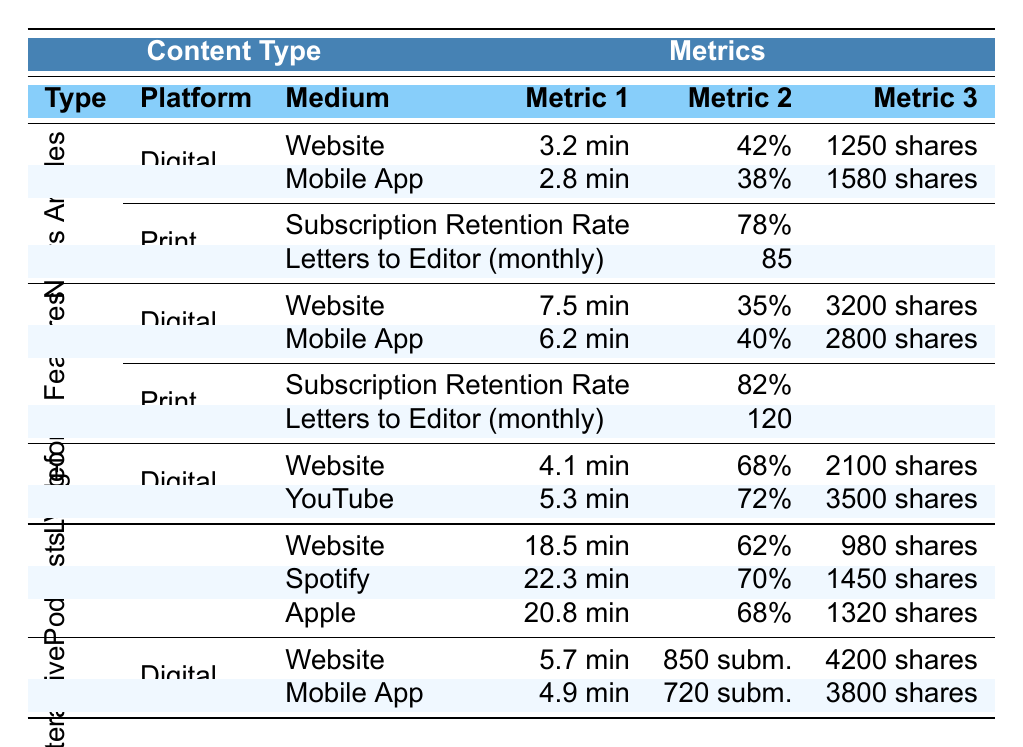What is the average time on the website for News Articles? The average time on the website for News Articles is provided in the table as 3.2 minutes.
Answer: 3.2 minutes Which platform has the highest completion rate for Video Content? The YouTube channel has the highest completion rate listed in the table, which is 72%.
Answer: 72% How many social shares does the Digital platform for Long-form Features on the website receive? The number of social shares for the Digital platform on the website is indicated as 3200.
Answer: 3200 shares What is the subscription retention rate for Print content in Long-form Features? The table shows that the subscription retention rate for Long-form Features in Print is 82%.
Answer: 82% Which medium for Podcasts has the highest average listen time? The Spotify platform has the highest average listen time of 22.3 minutes listed in the table.
Answer: 22.3 minutes Is the bounce rate for Digital News Articles higher on the website compared to the Mobile App? The bounce rate for the Digital News Articles is 42% on the website and 38% on the Mobile App, making the website's bounce rate higher.
Answer: Yes What is the difference in social shares between Long-form Features on the website and on the Mobile App? Long-form Features on the website have 3200 shares, while the Mobile App has 2800 shares. The difference is 3200 - 2800 = 400 shares.
Answer: 400 shares How does the average listen time for Apple Podcasts compare to the average listen time for Spotify? The average listen time for Apple Podcasts is 20.8 minutes, while for Spotify it is 22.3 minutes. Therefore, Spotify has a longer average listen time by 22.3 - 20.8 = 1.5 minutes.
Answer: 1.5 minutes longer Which Digital platform has the lowest average interaction time for Interactive Features? The Mobile App has the lowest average interaction time of 4.9 minutes compared to the website's 5.7 minutes.
Answer: 4.9 minutes What is the total number of social shares across all platforms for Interactive Features? The website has 4200 shares, and the Mobile App has 3800 shares, so the total is 4200 + 3800 = 8000 shares.
Answer: 8000 shares What is the completion rate for Podcasts on the Website Player? The completion rate for the Podcasts on the Website Player is given as 62% in the table.
Answer: 62% 